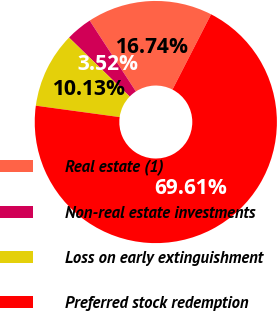Convert chart to OTSL. <chart><loc_0><loc_0><loc_500><loc_500><pie_chart><fcel>Real estate (1)<fcel>Non-real estate investments<fcel>Loss on early extinguishment<fcel>Preferred stock redemption<nl><fcel>16.74%<fcel>3.52%<fcel>10.13%<fcel>69.61%<nl></chart> 